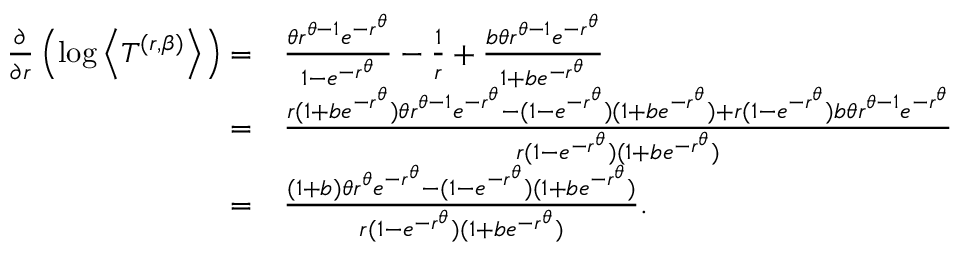<formula> <loc_0><loc_0><loc_500><loc_500>\begin{array} { r l } { \frac { \partial } { \partial r } \left ( \log \left \langle T ^ { ( r , \beta ) } \right \rangle \right ) = } & { \frac { \theta r ^ { \theta - 1 } e ^ { - r ^ { \theta } } } { 1 - e ^ { - r ^ { \theta } } } - \frac { 1 } { r } + \frac { b \theta r ^ { \theta - 1 } e ^ { - r ^ { \theta } } } { 1 + b e ^ { - r ^ { \theta } } } } \\ { = } & { \frac { r ( 1 + b e ^ { - r ^ { \theta } } ) \theta r ^ { \theta - 1 } e ^ { - r ^ { \theta } } - ( 1 - e ^ { - r ^ { \theta } } ) ( 1 + b e ^ { - r ^ { \theta } } ) + r ( 1 - e ^ { - r ^ { \theta } } ) b \theta r ^ { \theta - 1 } e ^ { - r ^ { \theta } } } { r ( 1 - e ^ { - r ^ { \theta } } ) ( 1 + b e ^ { - r ^ { \theta } } ) } } \\ { = } & { \frac { ( 1 + b ) \theta r ^ { \theta } e ^ { - r ^ { \theta } } - ( 1 - e ^ { - r ^ { \theta } } ) ( 1 + b e ^ { - r ^ { \theta } } ) } { r ( 1 - e ^ { - r ^ { \theta } } ) ( 1 + b e ^ { - r ^ { \theta } } ) } . } \end{array}</formula> 